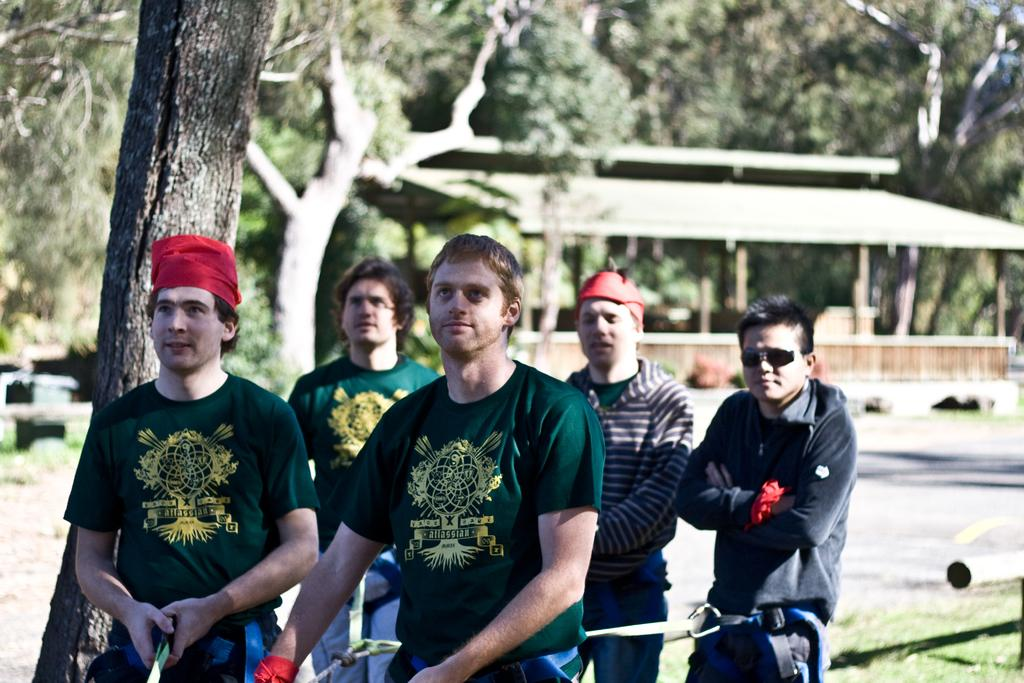What can be seen in the foreground of the image? There are persons standing in the front of the image. What is visible in the background of the image? There are trees and a shelter in the background of the image. What type of ground surface is present in the image? There is grass on the ground in the image. Can you tell me how many boxes are being carried by the goose in the image? There is no goose or box present in the image. What type of expert can be seen advising the persons in the image? There is no expert present in the image; it only shows persons standing in the front and a background with trees and a shelter. 